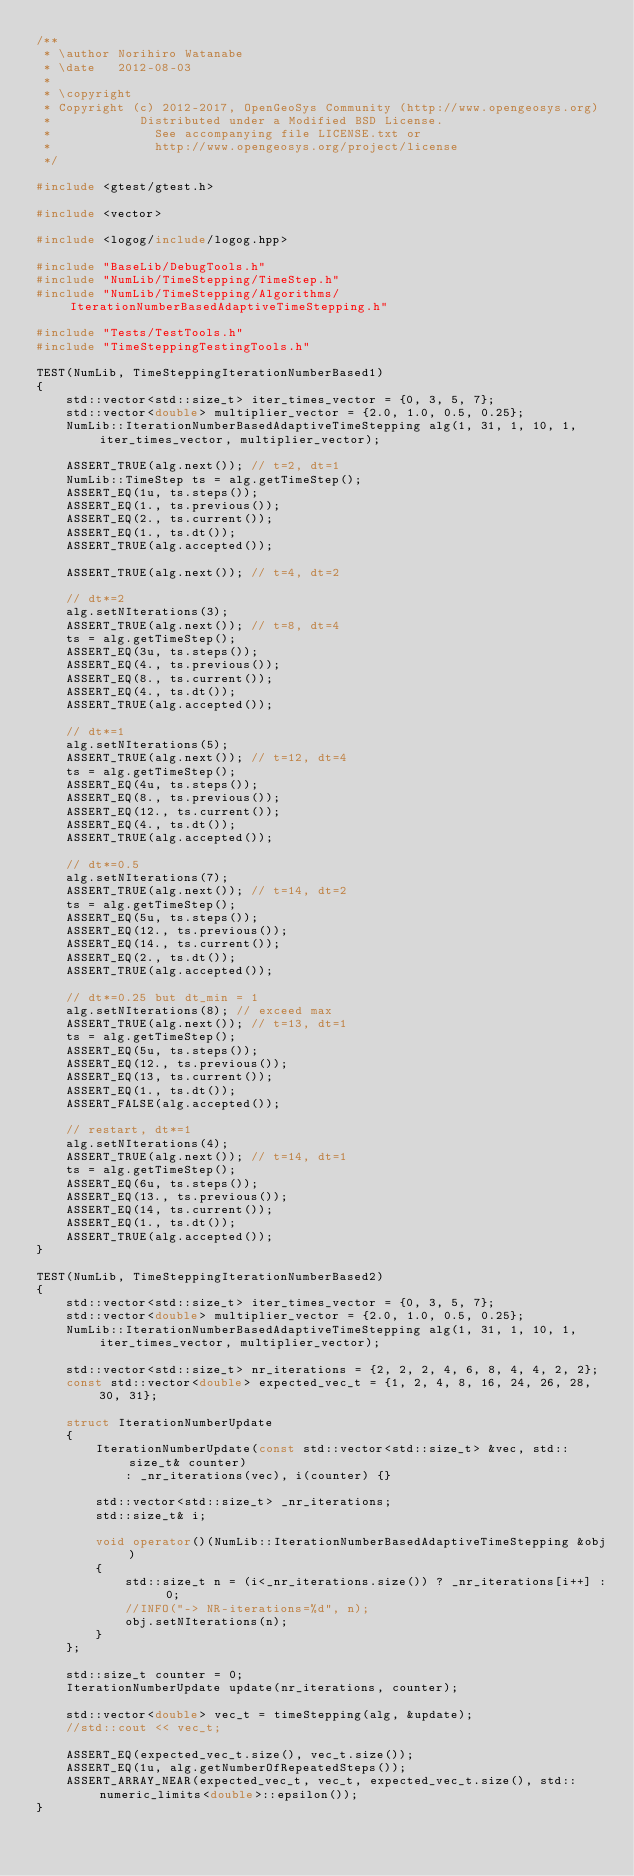Convert code to text. <code><loc_0><loc_0><loc_500><loc_500><_C++_>/**
 * \author Norihiro Watanabe
 * \date   2012-08-03
 *
 * \copyright
 * Copyright (c) 2012-2017, OpenGeoSys Community (http://www.opengeosys.org)
 *            Distributed under a Modified BSD License.
 *              See accompanying file LICENSE.txt or
 *              http://www.opengeosys.org/project/license
 */

#include <gtest/gtest.h>

#include <vector>

#include <logog/include/logog.hpp>

#include "BaseLib/DebugTools.h"
#include "NumLib/TimeStepping/TimeStep.h"
#include "NumLib/TimeStepping/Algorithms/IterationNumberBasedAdaptiveTimeStepping.h"

#include "Tests/TestTools.h"
#include "TimeSteppingTestingTools.h"

TEST(NumLib, TimeSteppingIterationNumberBased1)
{
    std::vector<std::size_t> iter_times_vector = {0, 3, 5, 7};
    std::vector<double> multiplier_vector = {2.0, 1.0, 0.5, 0.25};
    NumLib::IterationNumberBasedAdaptiveTimeStepping alg(1, 31, 1, 10, 1, iter_times_vector, multiplier_vector);

    ASSERT_TRUE(alg.next()); // t=2, dt=1
    NumLib::TimeStep ts = alg.getTimeStep();
    ASSERT_EQ(1u, ts.steps());
    ASSERT_EQ(1., ts.previous());
    ASSERT_EQ(2., ts.current());
    ASSERT_EQ(1., ts.dt());
    ASSERT_TRUE(alg.accepted());

    ASSERT_TRUE(alg.next()); // t=4, dt=2

    // dt*=2
    alg.setNIterations(3);
    ASSERT_TRUE(alg.next()); // t=8, dt=4
    ts = alg.getTimeStep();
    ASSERT_EQ(3u, ts.steps());
    ASSERT_EQ(4., ts.previous());
    ASSERT_EQ(8., ts.current());
    ASSERT_EQ(4., ts.dt());
    ASSERT_TRUE(alg.accepted());

    // dt*=1
    alg.setNIterations(5);
    ASSERT_TRUE(alg.next()); // t=12, dt=4
    ts = alg.getTimeStep();
    ASSERT_EQ(4u, ts.steps());
    ASSERT_EQ(8., ts.previous());
    ASSERT_EQ(12., ts.current());
    ASSERT_EQ(4., ts.dt());
    ASSERT_TRUE(alg.accepted());

    // dt*=0.5
    alg.setNIterations(7);
    ASSERT_TRUE(alg.next()); // t=14, dt=2
    ts = alg.getTimeStep();
    ASSERT_EQ(5u, ts.steps());
    ASSERT_EQ(12., ts.previous());
    ASSERT_EQ(14., ts.current());
    ASSERT_EQ(2., ts.dt());
    ASSERT_TRUE(alg.accepted());

    // dt*=0.25 but dt_min = 1
    alg.setNIterations(8); // exceed max
    ASSERT_TRUE(alg.next()); // t=13, dt=1
    ts = alg.getTimeStep();
    ASSERT_EQ(5u, ts.steps());
    ASSERT_EQ(12., ts.previous());
    ASSERT_EQ(13, ts.current());
    ASSERT_EQ(1., ts.dt());
    ASSERT_FALSE(alg.accepted());

    // restart, dt*=1
    alg.setNIterations(4);
    ASSERT_TRUE(alg.next()); // t=14, dt=1
    ts = alg.getTimeStep();
    ASSERT_EQ(6u, ts.steps());
    ASSERT_EQ(13., ts.previous());
    ASSERT_EQ(14, ts.current());
    ASSERT_EQ(1., ts.dt());
    ASSERT_TRUE(alg.accepted());
}

TEST(NumLib, TimeSteppingIterationNumberBased2)
{
    std::vector<std::size_t> iter_times_vector = {0, 3, 5, 7};
    std::vector<double> multiplier_vector = {2.0, 1.0, 0.5, 0.25};
    NumLib::IterationNumberBasedAdaptiveTimeStepping alg(1, 31, 1, 10, 1, iter_times_vector, multiplier_vector);

    std::vector<std::size_t> nr_iterations = {2, 2, 2, 4, 6, 8, 4, 4, 2, 2};
    const std::vector<double> expected_vec_t = {1, 2, 4, 8, 16, 24, 26, 28, 30, 31};

    struct IterationNumberUpdate
    {
        IterationNumberUpdate(const std::vector<std::size_t> &vec, std::size_t& counter)
            : _nr_iterations(vec), i(counter) {}

        std::vector<std::size_t> _nr_iterations;
        std::size_t& i;

        void operator()(NumLib::IterationNumberBasedAdaptiveTimeStepping &obj)
        {
            std::size_t n = (i<_nr_iterations.size()) ? _nr_iterations[i++] : 0;
            //INFO("-> NR-iterations=%d", n);
            obj.setNIterations(n);
        }
    };

    std::size_t counter = 0;
    IterationNumberUpdate update(nr_iterations, counter);

    std::vector<double> vec_t = timeStepping(alg, &update);
    //std::cout << vec_t;

    ASSERT_EQ(expected_vec_t.size(), vec_t.size());
    ASSERT_EQ(1u, alg.getNumberOfRepeatedSteps());
    ASSERT_ARRAY_NEAR(expected_vec_t, vec_t, expected_vec_t.size(), std::numeric_limits<double>::epsilon());
}
</code> 